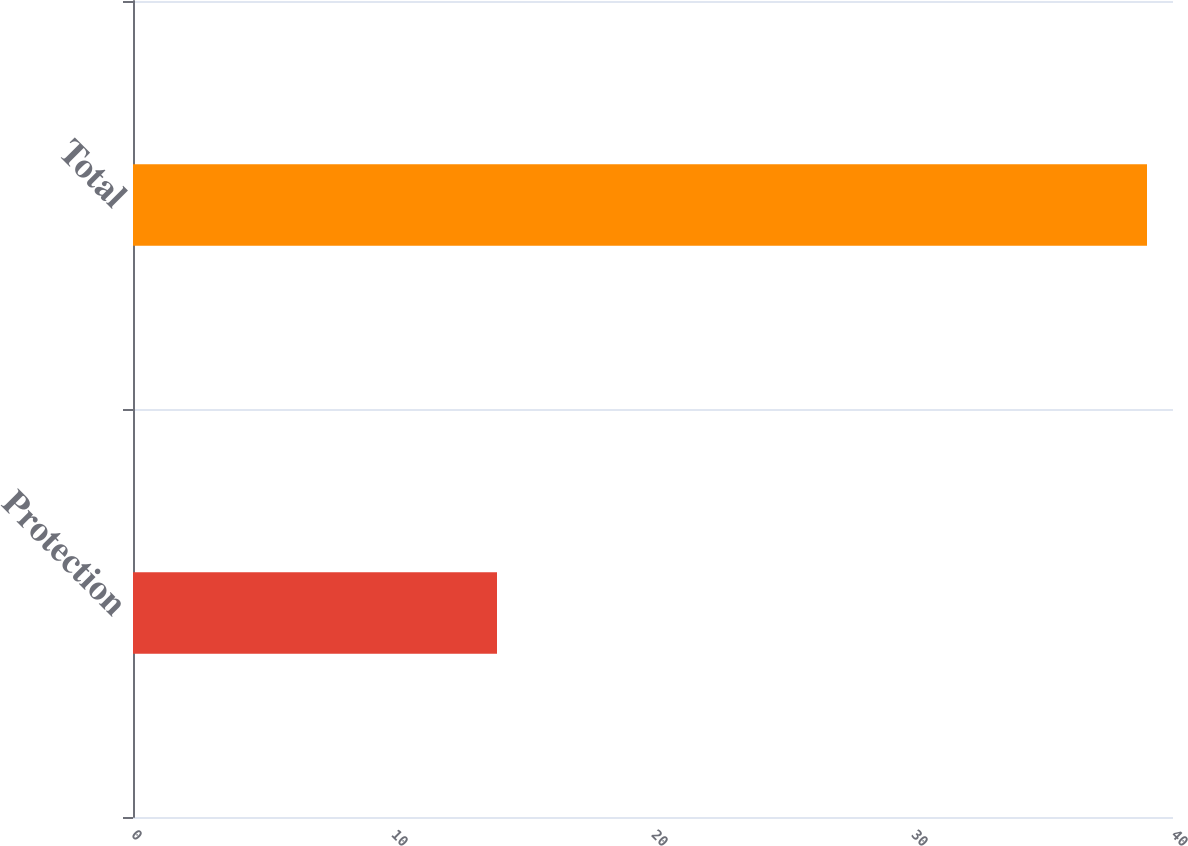Convert chart to OTSL. <chart><loc_0><loc_0><loc_500><loc_500><bar_chart><fcel>Protection<fcel>Total<nl><fcel>14<fcel>39<nl></chart> 